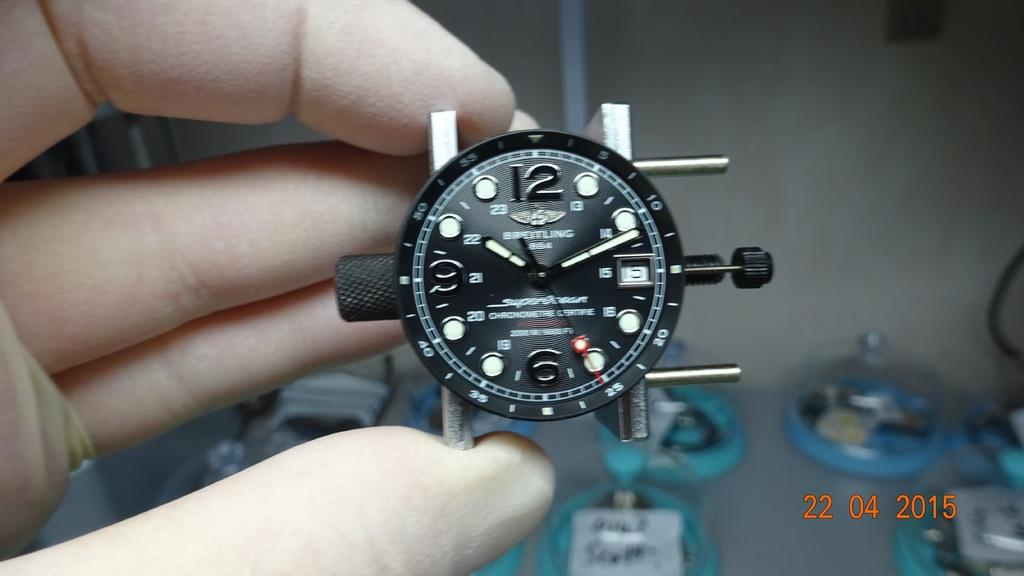<image>
Summarize the visual content of the image. A black and white watch showing the time as 10:10. 